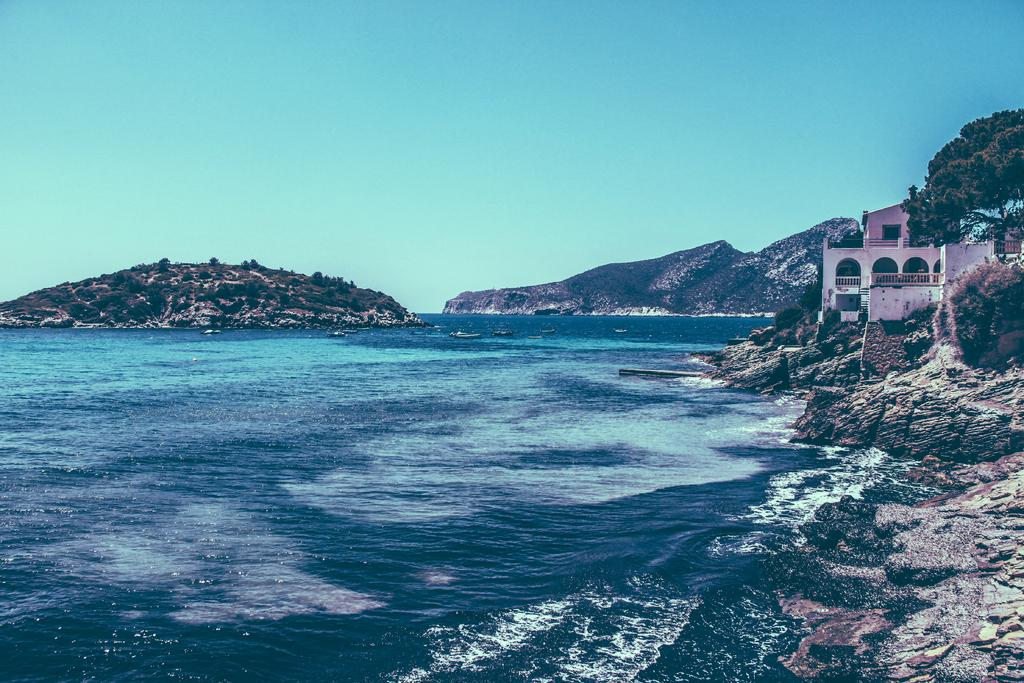What type of natural feature is present in the image? There is an ocean in the image. What other natural feature can be seen in the image? There are mountains in the image. What man-made structure is located on the right side of the image? There is a building on the right side of the image. What type of vegetation is present on the right side of the image? There are trees on the right side of the image. Where is the cemetery located in the image? There is no cemetery present in the image. What type of flame can be seen coming from the mountains in the image? There are no flames present in the image; the mountains are not on fire. 